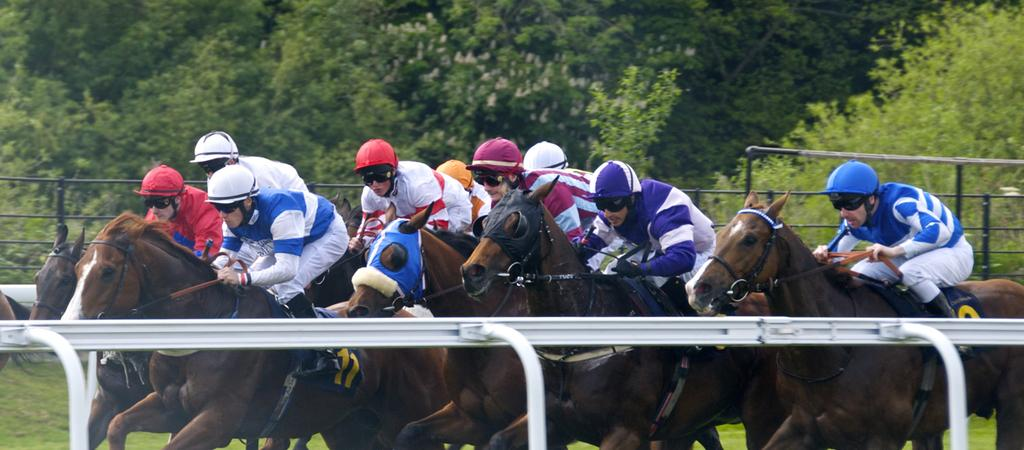What are the people in the image doing? The people in the image are riding on horses. What safety equipment are the riders wearing? The people are wearing helmets. What is surrounding the riders in the image? There is a fence around the riders. What can be seen in the background of the image? There are trees in the background of the image. What time does the clock show in the image? There is no clock present in the image. What type of animal is the minister riding in the image? There is no minister or donkey present in the image; it features people riding horses. 